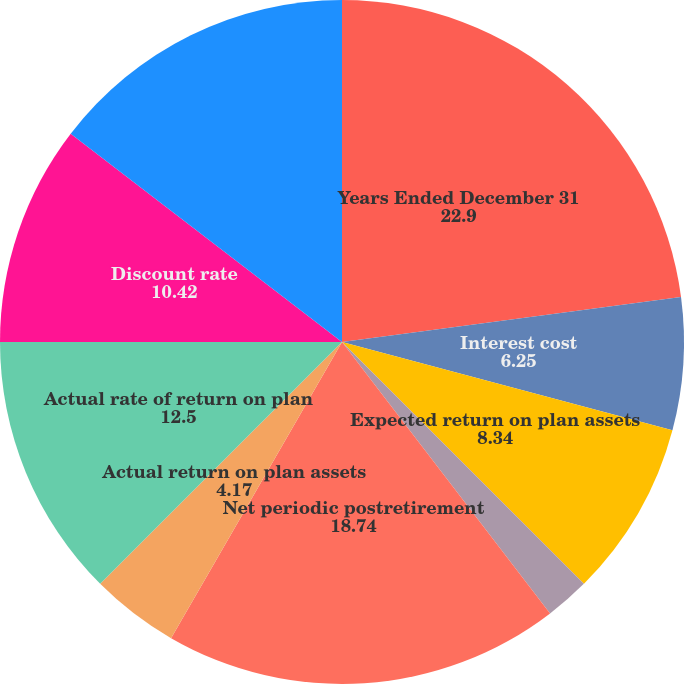Convert chart to OTSL. <chart><loc_0><loc_0><loc_500><loc_500><pie_chart><fcel>Years Ended December 31<fcel>Interest cost<fcel>Expected return on plan assets<fcel>Amortization of prior service<fcel>Amortization of net loss<fcel>Net periodic postretirement<fcel>Actual return on plan assets<fcel>Actual rate of return on plan<fcel>Discount rate<fcel>Expected long-term return on<nl><fcel>22.9%<fcel>6.25%<fcel>8.34%<fcel>0.01%<fcel>2.09%<fcel>18.74%<fcel>4.17%<fcel>12.5%<fcel>10.42%<fcel>14.58%<nl></chart> 